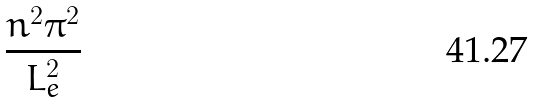<formula> <loc_0><loc_0><loc_500><loc_500>\frac { n ^ { 2 } \pi ^ { 2 } } { L _ { e } ^ { 2 } }</formula> 